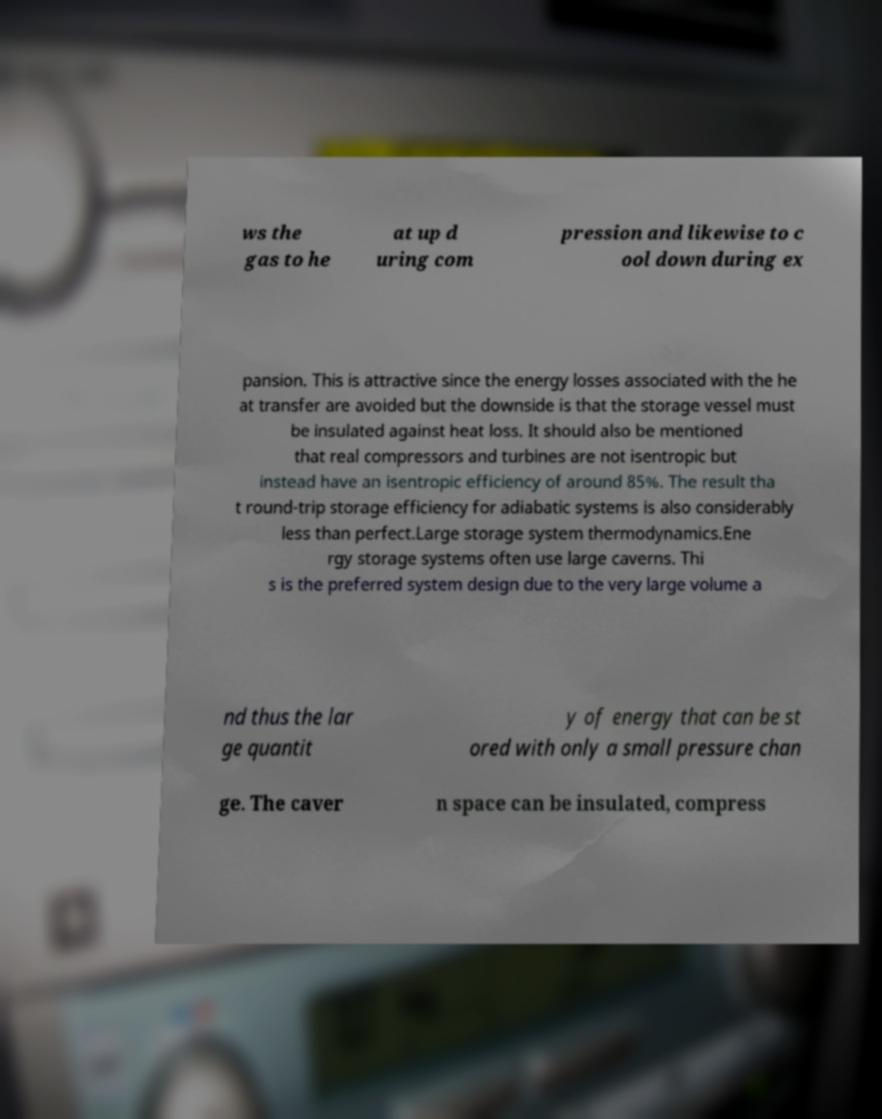There's text embedded in this image that I need extracted. Can you transcribe it verbatim? ws the gas to he at up d uring com pression and likewise to c ool down during ex pansion. This is attractive since the energy losses associated with the he at transfer are avoided but the downside is that the storage vessel must be insulated against heat loss. It should also be mentioned that real compressors and turbines are not isentropic but instead have an isentropic efficiency of around 85%. The result tha t round-trip storage efficiency for adiabatic systems is also considerably less than perfect.Large storage system thermodynamics.Ene rgy storage systems often use large caverns. Thi s is the preferred system design due to the very large volume a nd thus the lar ge quantit y of energy that can be st ored with only a small pressure chan ge. The caver n space can be insulated, compress 